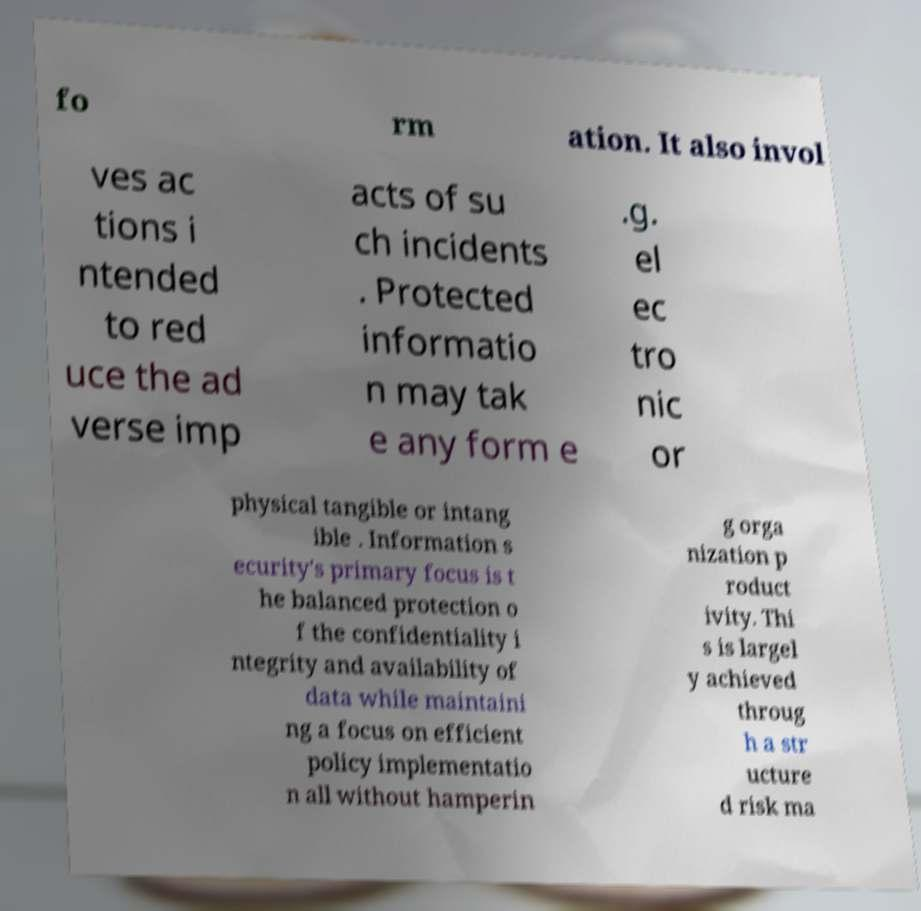There's text embedded in this image that I need extracted. Can you transcribe it verbatim? fo rm ation. It also invol ves ac tions i ntended to red uce the ad verse imp acts of su ch incidents . Protected informatio n may tak e any form e .g. el ec tro nic or physical tangible or intang ible . Information s ecurity's primary focus is t he balanced protection o f the confidentiality i ntegrity and availability of data while maintaini ng a focus on efficient policy implementatio n all without hamperin g orga nization p roduct ivity. Thi s is largel y achieved throug h a str ucture d risk ma 